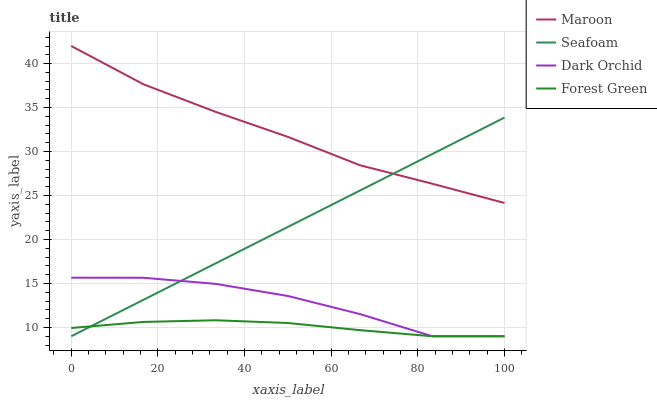Does Forest Green have the minimum area under the curve?
Answer yes or no. Yes. Does Maroon have the maximum area under the curve?
Answer yes or no. Yes. Does Seafoam have the minimum area under the curve?
Answer yes or no. No. Does Seafoam have the maximum area under the curve?
Answer yes or no. No. Is Seafoam the smoothest?
Answer yes or no. Yes. Is Dark Orchid the roughest?
Answer yes or no. Yes. Is Forest Green the smoothest?
Answer yes or no. No. Is Forest Green the roughest?
Answer yes or no. No. Does Dark Orchid have the lowest value?
Answer yes or no. Yes. Does Maroon have the lowest value?
Answer yes or no. No. Does Maroon have the highest value?
Answer yes or no. Yes. Does Seafoam have the highest value?
Answer yes or no. No. Is Forest Green less than Maroon?
Answer yes or no. Yes. Is Maroon greater than Dark Orchid?
Answer yes or no. Yes. Does Forest Green intersect Seafoam?
Answer yes or no. Yes. Is Forest Green less than Seafoam?
Answer yes or no. No. Is Forest Green greater than Seafoam?
Answer yes or no. No. Does Forest Green intersect Maroon?
Answer yes or no. No. 